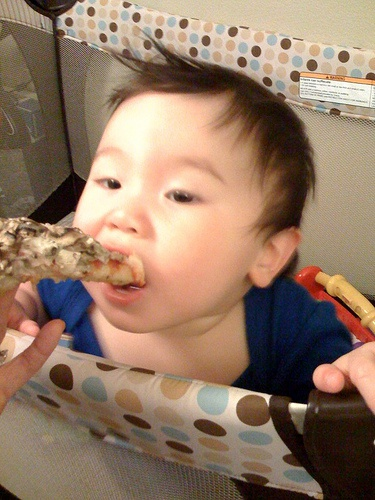Describe the objects in this image and their specific colors. I can see people in tan, black, and salmon tones and pizza in tan and gray tones in this image. 